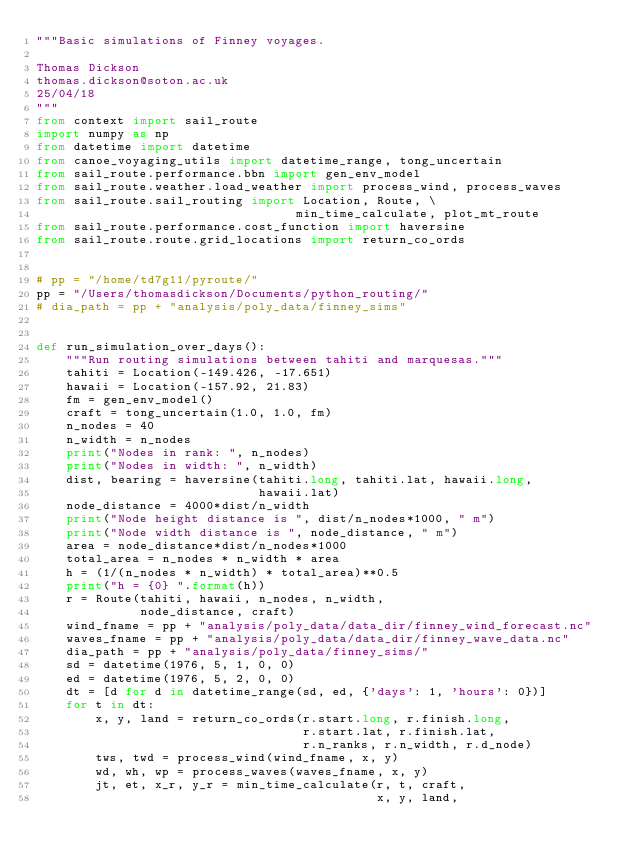<code> <loc_0><loc_0><loc_500><loc_500><_Python_>"""Basic simulations of Finney voyages.

Thomas Dickson
thomas.dickson@soton.ac.uk
25/04/18
"""
from context import sail_route
import numpy as np
from datetime import datetime
from canoe_voyaging_utils import datetime_range, tong_uncertain
from sail_route.performance.bbn import gen_env_model
from sail_route.weather.load_weather import process_wind, process_waves
from sail_route.sail_routing import Location, Route, \
                                   min_time_calculate, plot_mt_route
from sail_route.performance.cost_function import haversine
from sail_route.route.grid_locations import return_co_ords


# pp = "/home/td7g11/pyroute/"
pp = "/Users/thomasdickson/Documents/python_routing/"
# dia_path = pp + "analysis/poly_data/finney_sims"


def run_simulation_over_days():
    """Run routing simulations between tahiti and marquesas."""
    tahiti = Location(-149.426, -17.651)
    hawaii = Location(-157.92, 21.83)
    fm = gen_env_model()
    craft = tong_uncertain(1.0, 1.0, fm)
    n_nodes = 40
    n_width = n_nodes
    print("Nodes in rank: ", n_nodes)
    print("Nodes in width: ", n_width)
    dist, bearing = haversine(tahiti.long, tahiti.lat, hawaii.long,
                              hawaii.lat)
    node_distance = 4000*dist/n_width
    print("Node height distance is ", dist/n_nodes*1000, " m")
    print("Node width distance is ", node_distance, " m")
    area = node_distance*dist/n_nodes*1000
    total_area = n_nodes * n_width * area
    h = (1/(n_nodes * n_width) * total_area)**0.5
    print("h = {0} ".format(h))
    r = Route(tahiti, hawaii, n_nodes, n_width,
              node_distance, craft)
    wind_fname = pp + "analysis/poly_data/data_dir/finney_wind_forecast.nc"
    waves_fname = pp + "analysis/poly_data/data_dir/finney_wave_data.nc"
    dia_path = pp + "analysis/poly_data/finney_sims/"
    sd = datetime(1976, 5, 1, 0, 0)
    ed = datetime(1976, 5, 2, 0, 0)
    dt = [d for d in datetime_range(sd, ed, {'days': 1, 'hours': 0})]
    for t in dt:
        x, y, land = return_co_ords(r.start.long, r.finish.long,
                                    r.start.lat, r.finish.lat,
                                    r.n_ranks, r.n_width, r.d_node)
        tws, twd = process_wind(wind_fname, x, y)
        wd, wh, wp = process_waves(waves_fname, x, y)
        jt, et, x_r, y_r = min_time_calculate(r, t, craft,
                                              x, y, land,</code> 